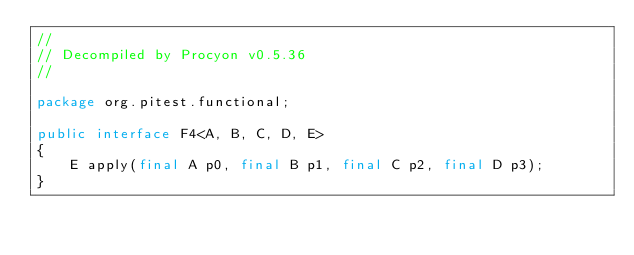Convert code to text. <code><loc_0><loc_0><loc_500><loc_500><_Java_>// 
// Decompiled by Procyon v0.5.36
// 

package org.pitest.functional;

public interface F4<A, B, C, D, E>
{
    E apply(final A p0, final B p1, final C p2, final D p3);
}
</code> 